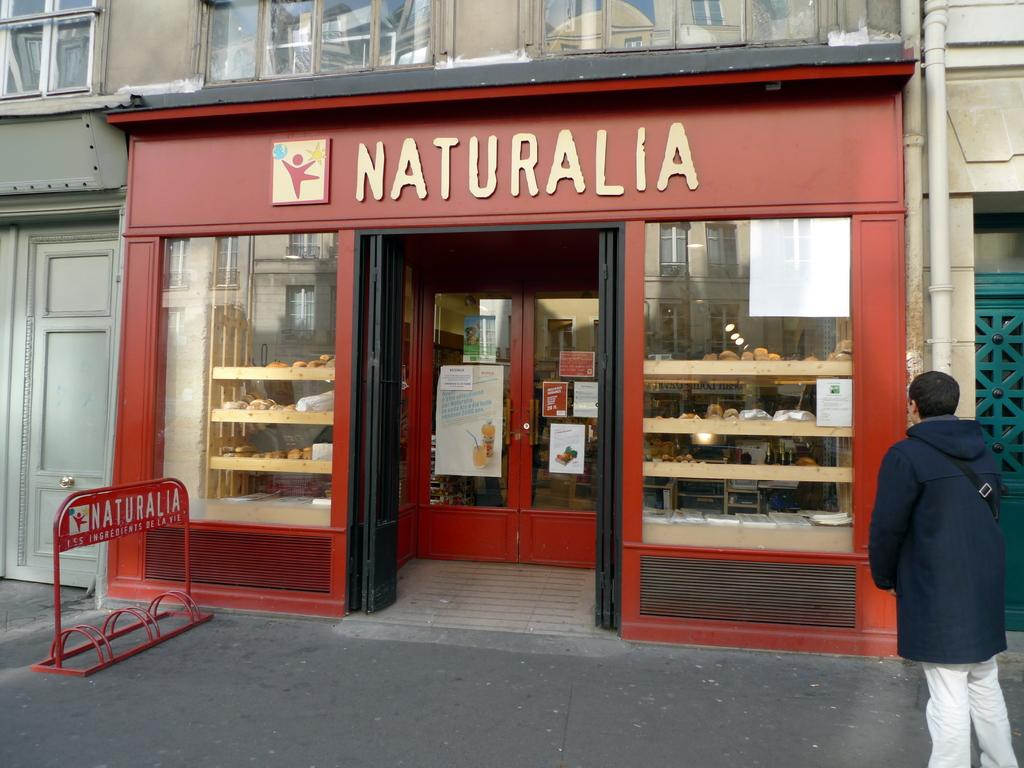What type of structure is present in the image? There is a building in the image. What kind of establishment can be found in the building? There is a food store in the building. What decorative elements are visible in the image? There are posters in the image. What type of infrastructure is present in the image? There are pipes in the image. What safety feature is present in the image? There is a barrier in the image. What is the person in the image doing? There is a person standing on the road in the image. How long does it take for the person to cough in the image? There is no indication of the person coughing in the image, so it cannot be determined. What type of rail is present in the image? There is no rail present in the image. 